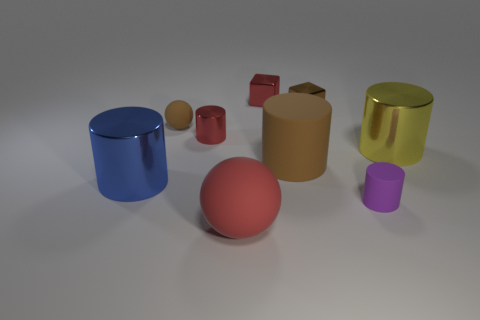How many other purple things are the same shape as the small purple thing?
Your response must be concise. 0. There is a red object behind the tiny cylinder behind the large brown rubber thing; what is its size?
Provide a short and direct response. Small. What number of cyan things are small metallic cubes or small spheres?
Provide a short and direct response. 0. Is the number of brown matte spheres in front of the yellow object less than the number of red cubes in front of the purple cylinder?
Provide a short and direct response. No. There is a blue shiny cylinder; does it have the same size as the red metallic object behind the tiny brown metallic object?
Your answer should be very brief. No. What number of brown spheres have the same size as the red rubber object?
Your response must be concise. 0. How many large objects are rubber spheres or yellow metallic cylinders?
Provide a short and direct response. 2. Is there a tiny red shiny sphere?
Your response must be concise. No. Are there more tiny red objects that are on the left side of the brown metallic thing than big yellow shiny cylinders in front of the large blue cylinder?
Give a very brief answer. Yes. What color is the small metal thing left of the rubber ball that is on the right side of the brown matte sphere?
Make the answer very short. Red. 